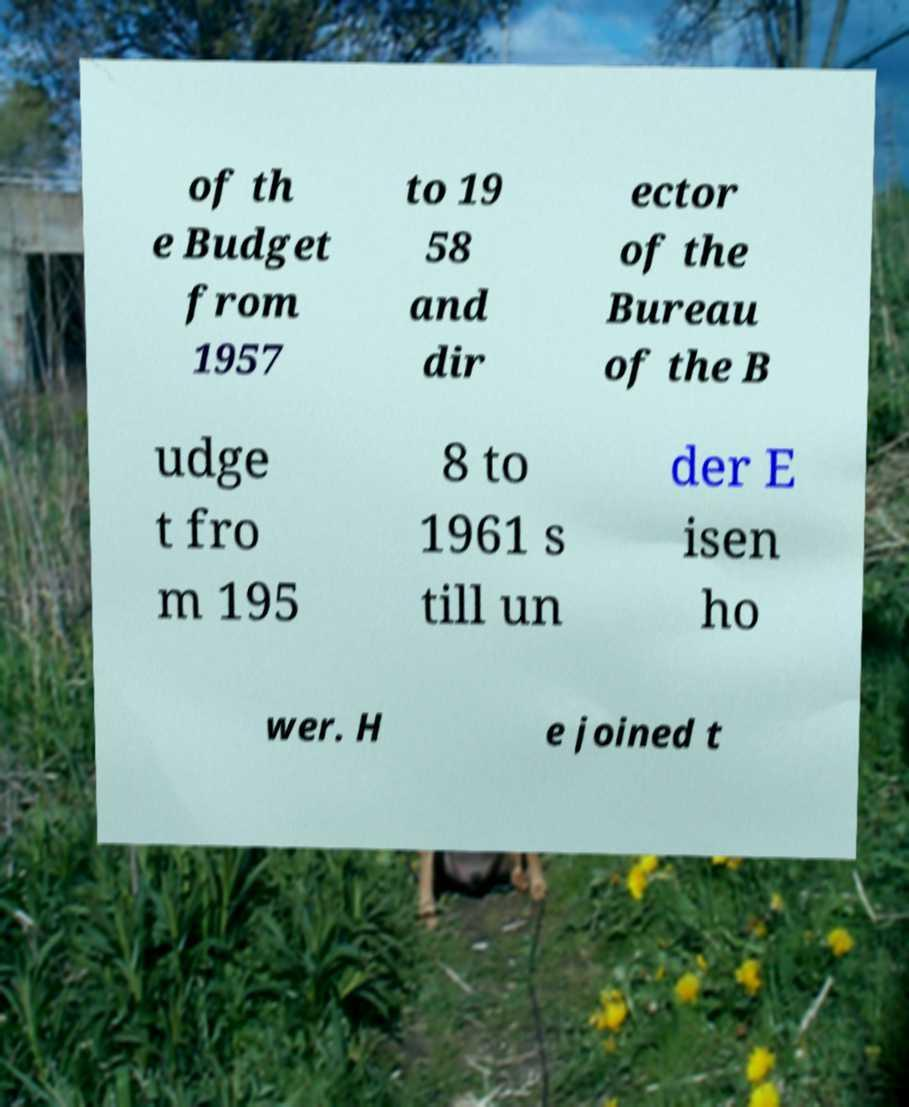Could you extract and type out the text from this image? of th e Budget from 1957 to 19 58 and dir ector of the Bureau of the B udge t fro m 195 8 to 1961 s till un der E isen ho wer. H e joined t 